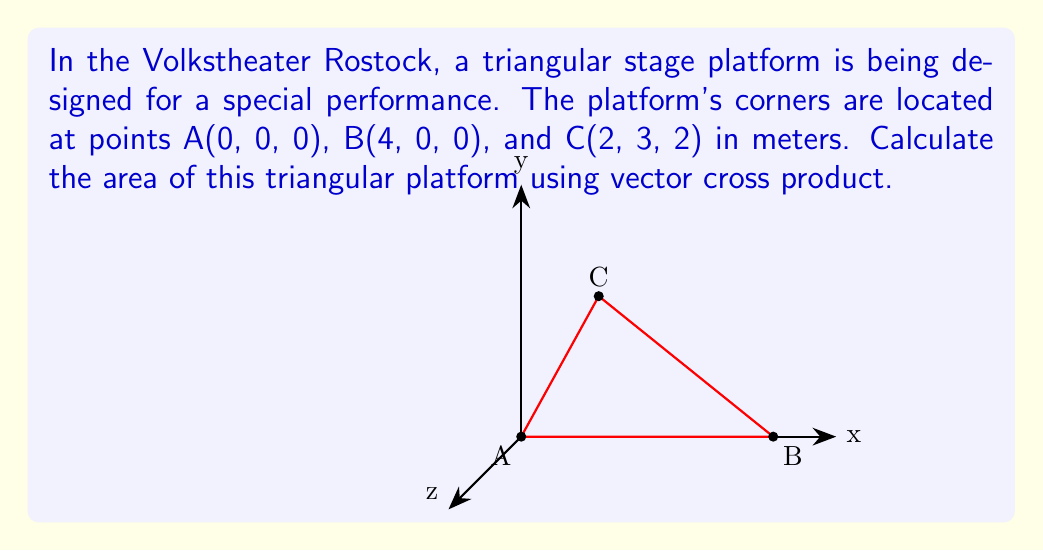Give your solution to this math problem. To find the area of the triangular platform using vector cross product, we'll follow these steps:

1) First, we need to create two vectors from the given points:
   $\vec{AB} = B - A = (4-0, 0-0, 0-0) = (4, 0, 0)$
   $\vec{AC} = C - A = (2-0, 3-0, 2-0) = (2, 3, 2)$

2) The area of the triangle is half the magnitude of the cross product of these vectors:
   Area = $\frac{1}{2}|\vec{AB} \times \vec{AC}|$

3) Let's calculate the cross product:
   $$\vec{AB} \times \vec{AC} = \begin{vmatrix} 
   \mathbf{i} & \mathbf{j} & \mathbf{k} \\
   4 & 0 & 0 \\
   2 & 3 & 2
   \end{vmatrix}$$

4) Expanding the determinant:
   $\vec{AB} \times \vec{AC} = (0\cdot2 - 0\cdot3)\mathbf{i} - (4\cdot2 - 0\cdot2)\mathbf{j} + (4\cdot3 - 0\cdot2)\mathbf{k}$
   $= 0\mathbf{i} - 8\mathbf{j} + 12\mathbf{k}$

5) The magnitude of this vector is:
   $|\vec{AB} \times \vec{AC}| = \sqrt{0^2 + (-8)^2 + 12^2} = \sqrt{64 + 144} = \sqrt{208} = 4\sqrt{13}$

6) Therefore, the area of the triangle is:
   Area = $\frac{1}{2} \cdot 4\sqrt{13} = 2\sqrt{13}$ square meters
Answer: $2\sqrt{13}$ m² 